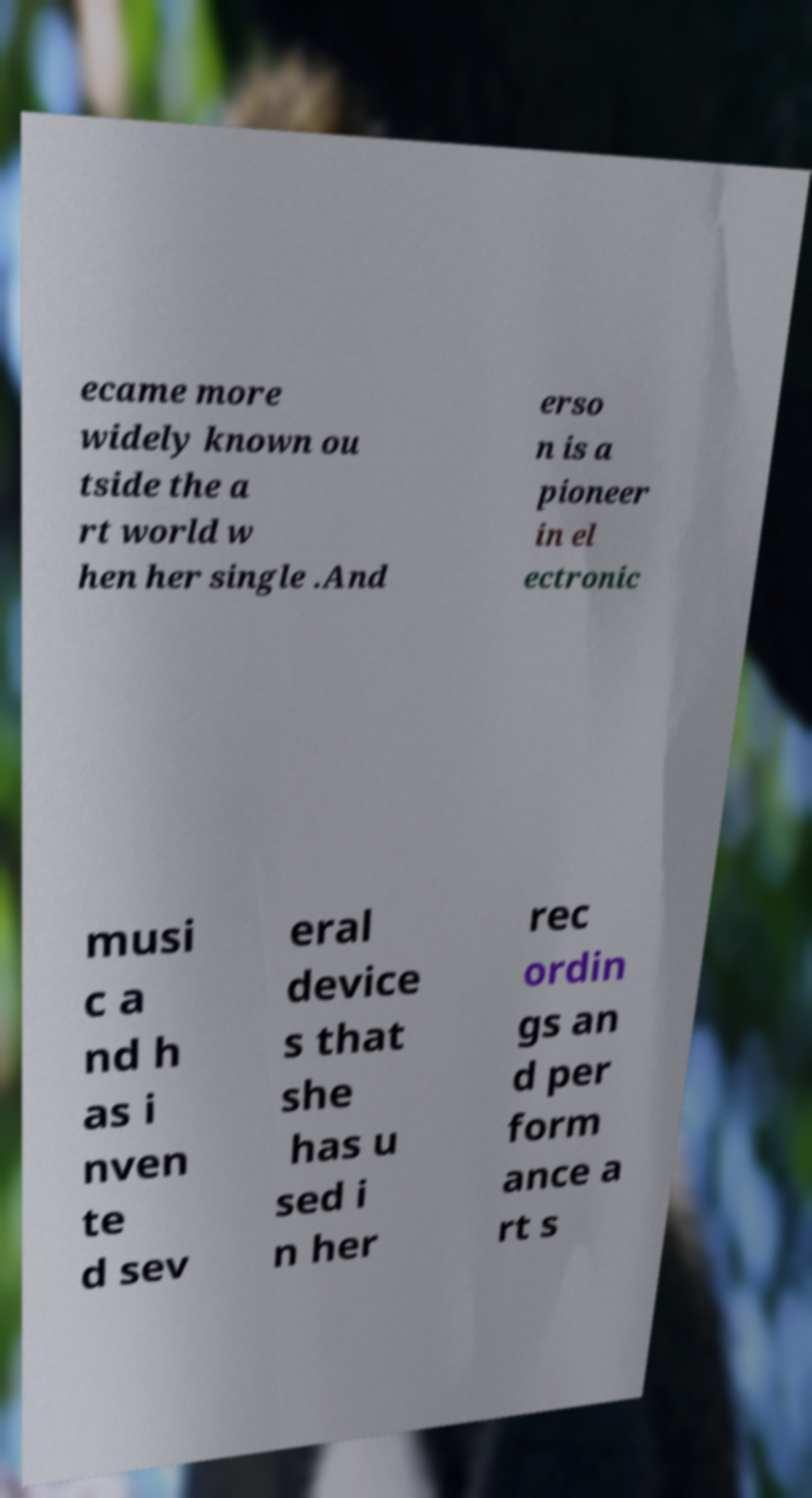Can you read and provide the text displayed in the image?This photo seems to have some interesting text. Can you extract and type it out for me? ecame more widely known ou tside the a rt world w hen her single .And erso n is a pioneer in el ectronic musi c a nd h as i nven te d sev eral device s that she has u sed i n her rec ordin gs an d per form ance a rt s 